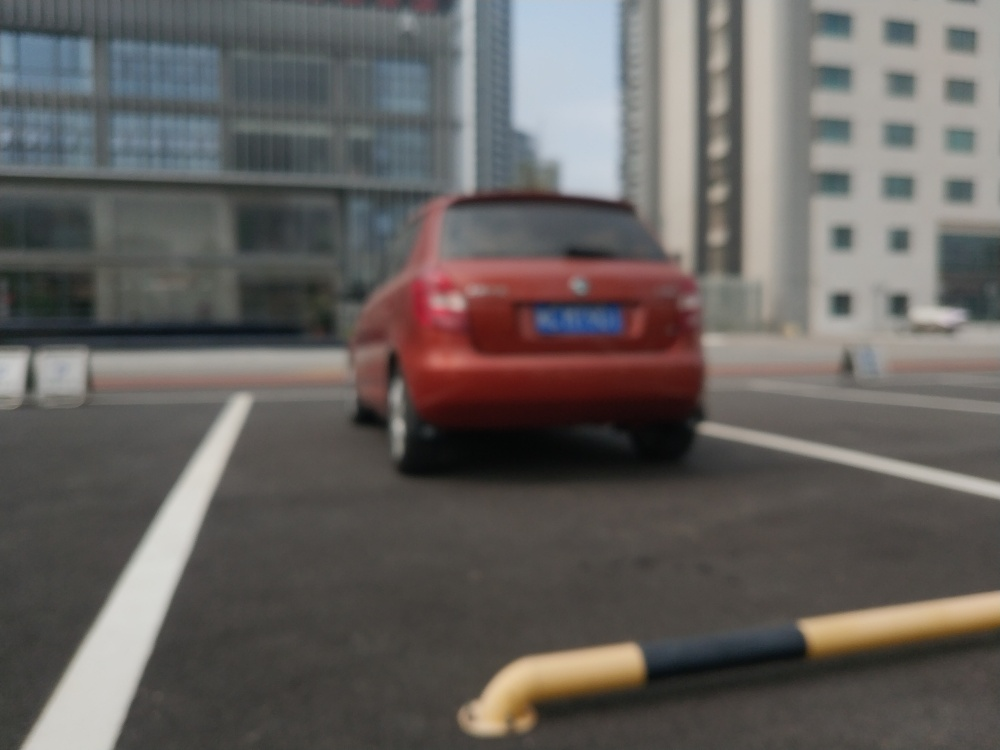What time of day does it appear to be in the image, and what clues lead to that conclusion? The lighting suggests that this could be midday or early afternoon due to the bright, diffused light, without strong shadows that would indicate a lower sun angle. The image's overall visibility, despite the blurriness, and the lack of activity also contribute to this impression. 